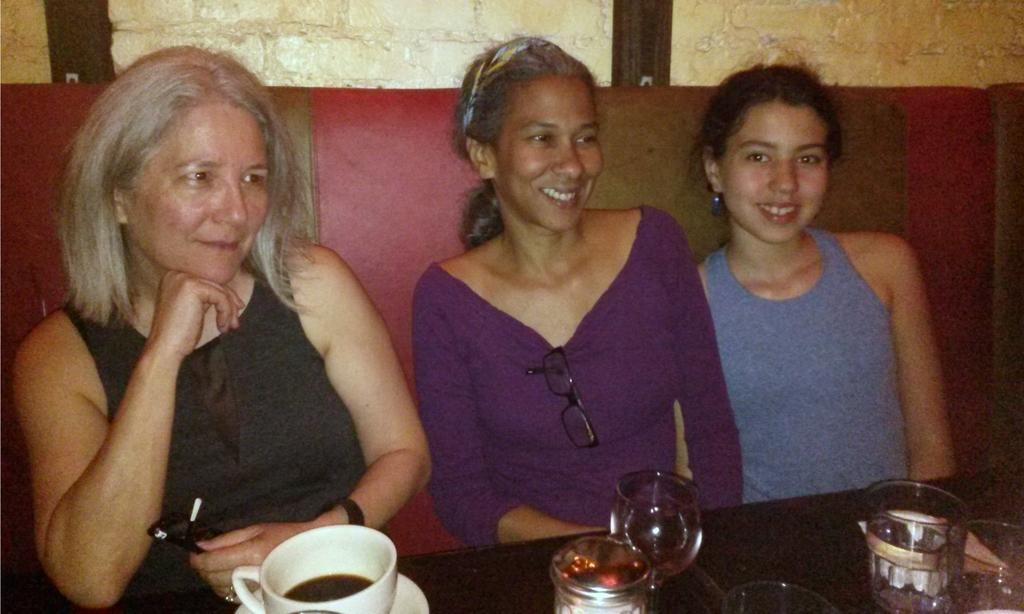How many women are in the image? There are three women in the image. What are the women doing in the image? The women are sitting on a sofa. What is in front of the sofa? There is a table in front of the sofa. What items can be seen on the table? There is a cup and saucer, as well as glasses on the table. What is the facial expression of the women in the image? The women are smiling. Where is the bucket located in the image? There is no bucket present in the image. What error can be seen in the image? There is no error visible in the image. 